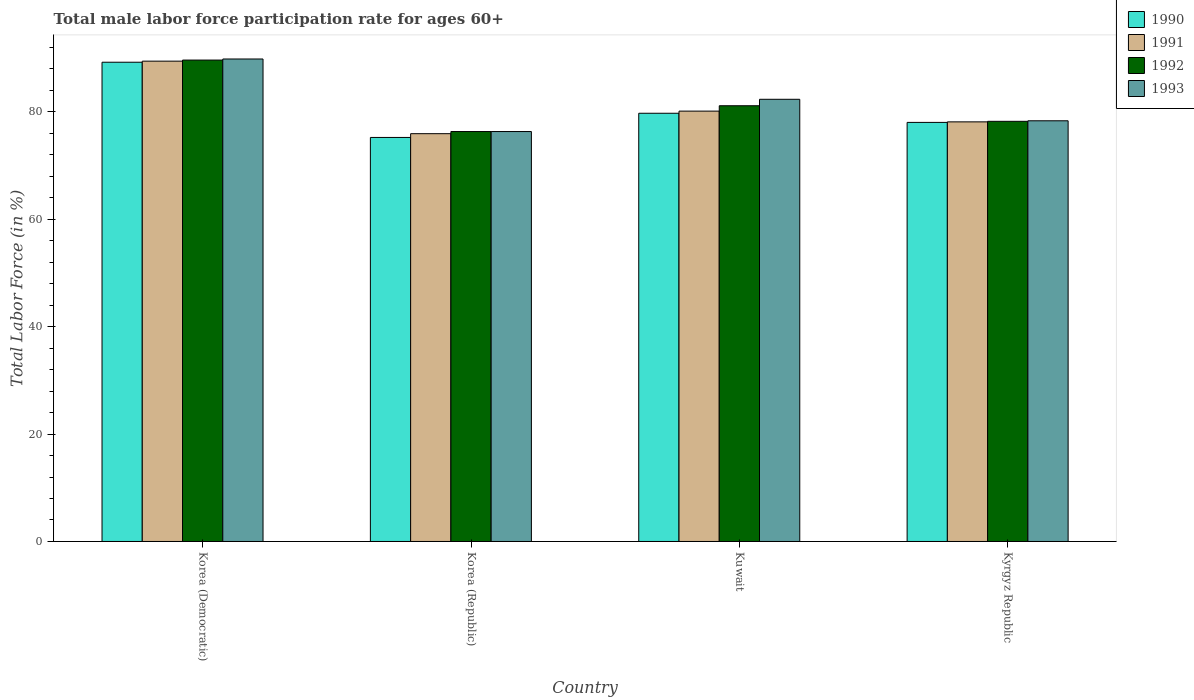How many groups of bars are there?
Make the answer very short. 4. Are the number of bars on each tick of the X-axis equal?
Offer a very short reply. Yes. What is the label of the 3rd group of bars from the left?
Keep it short and to the point. Kuwait. What is the male labor force participation rate in 1990 in Korea (Democratic)?
Give a very brief answer. 89.2. Across all countries, what is the maximum male labor force participation rate in 1991?
Your answer should be compact. 89.4. Across all countries, what is the minimum male labor force participation rate in 1990?
Your answer should be compact. 75.2. In which country was the male labor force participation rate in 1991 maximum?
Offer a very short reply. Korea (Democratic). In which country was the male labor force participation rate in 1993 minimum?
Offer a very short reply. Korea (Republic). What is the total male labor force participation rate in 1990 in the graph?
Ensure brevity in your answer.  322.1. What is the difference between the male labor force participation rate in 1992 in Korea (Republic) and that in Kuwait?
Provide a short and direct response. -4.8. What is the difference between the male labor force participation rate in 1990 in Korea (Republic) and the male labor force participation rate in 1991 in Kuwait?
Offer a terse response. -4.9. What is the average male labor force participation rate in 1991 per country?
Your answer should be very brief. 80.87. What is the ratio of the male labor force participation rate in 1992 in Korea (Republic) to that in Kuwait?
Keep it short and to the point. 0.94. Is the difference between the male labor force participation rate in 1992 in Korea (Democratic) and Kuwait greater than the difference between the male labor force participation rate in 1993 in Korea (Democratic) and Kuwait?
Your answer should be compact. Yes. What is the difference between the highest and the second highest male labor force participation rate in 1991?
Give a very brief answer. -9.3. In how many countries, is the male labor force participation rate in 1993 greater than the average male labor force participation rate in 1993 taken over all countries?
Offer a very short reply. 2. What does the 1st bar from the left in Korea (Republic) represents?
Make the answer very short. 1990. What does the 2nd bar from the right in Kyrgyz Republic represents?
Your response must be concise. 1992. Is it the case that in every country, the sum of the male labor force participation rate in 1992 and male labor force participation rate in 1993 is greater than the male labor force participation rate in 1990?
Make the answer very short. Yes. What is the difference between two consecutive major ticks on the Y-axis?
Provide a short and direct response. 20. Does the graph contain any zero values?
Make the answer very short. No. How are the legend labels stacked?
Your answer should be very brief. Vertical. What is the title of the graph?
Keep it short and to the point. Total male labor force participation rate for ages 60+. What is the label or title of the X-axis?
Keep it short and to the point. Country. What is the Total Labor Force (in %) in 1990 in Korea (Democratic)?
Provide a short and direct response. 89.2. What is the Total Labor Force (in %) in 1991 in Korea (Democratic)?
Your answer should be compact. 89.4. What is the Total Labor Force (in %) of 1992 in Korea (Democratic)?
Your response must be concise. 89.6. What is the Total Labor Force (in %) of 1993 in Korea (Democratic)?
Your answer should be compact. 89.8. What is the Total Labor Force (in %) in 1990 in Korea (Republic)?
Make the answer very short. 75.2. What is the Total Labor Force (in %) in 1991 in Korea (Republic)?
Ensure brevity in your answer.  75.9. What is the Total Labor Force (in %) in 1992 in Korea (Republic)?
Give a very brief answer. 76.3. What is the Total Labor Force (in %) in 1993 in Korea (Republic)?
Your response must be concise. 76.3. What is the Total Labor Force (in %) of 1990 in Kuwait?
Keep it short and to the point. 79.7. What is the Total Labor Force (in %) of 1991 in Kuwait?
Ensure brevity in your answer.  80.1. What is the Total Labor Force (in %) of 1992 in Kuwait?
Give a very brief answer. 81.1. What is the Total Labor Force (in %) in 1993 in Kuwait?
Provide a succinct answer. 82.3. What is the Total Labor Force (in %) in 1991 in Kyrgyz Republic?
Ensure brevity in your answer.  78.1. What is the Total Labor Force (in %) in 1992 in Kyrgyz Republic?
Your response must be concise. 78.2. What is the Total Labor Force (in %) of 1993 in Kyrgyz Republic?
Make the answer very short. 78.3. Across all countries, what is the maximum Total Labor Force (in %) in 1990?
Provide a short and direct response. 89.2. Across all countries, what is the maximum Total Labor Force (in %) of 1991?
Your response must be concise. 89.4. Across all countries, what is the maximum Total Labor Force (in %) of 1992?
Provide a succinct answer. 89.6. Across all countries, what is the maximum Total Labor Force (in %) of 1993?
Provide a short and direct response. 89.8. Across all countries, what is the minimum Total Labor Force (in %) of 1990?
Your response must be concise. 75.2. Across all countries, what is the minimum Total Labor Force (in %) of 1991?
Offer a terse response. 75.9. Across all countries, what is the minimum Total Labor Force (in %) of 1992?
Your response must be concise. 76.3. Across all countries, what is the minimum Total Labor Force (in %) in 1993?
Provide a succinct answer. 76.3. What is the total Total Labor Force (in %) of 1990 in the graph?
Provide a succinct answer. 322.1. What is the total Total Labor Force (in %) of 1991 in the graph?
Keep it short and to the point. 323.5. What is the total Total Labor Force (in %) in 1992 in the graph?
Keep it short and to the point. 325.2. What is the total Total Labor Force (in %) in 1993 in the graph?
Your response must be concise. 326.7. What is the difference between the Total Labor Force (in %) in 1991 in Korea (Democratic) and that in Korea (Republic)?
Your answer should be compact. 13.5. What is the difference between the Total Labor Force (in %) of 1992 in Korea (Democratic) and that in Korea (Republic)?
Provide a succinct answer. 13.3. What is the difference between the Total Labor Force (in %) in 1993 in Korea (Democratic) and that in Korea (Republic)?
Your response must be concise. 13.5. What is the difference between the Total Labor Force (in %) in 1992 in Korea (Democratic) and that in Kuwait?
Keep it short and to the point. 8.5. What is the difference between the Total Labor Force (in %) in 1993 in Korea (Democratic) and that in Kuwait?
Make the answer very short. 7.5. What is the difference between the Total Labor Force (in %) in 1990 in Korea (Democratic) and that in Kyrgyz Republic?
Offer a very short reply. 11.2. What is the difference between the Total Labor Force (in %) of 1991 in Korea (Democratic) and that in Kyrgyz Republic?
Your answer should be compact. 11.3. What is the difference between the Total Labor Force (in %) in 1991 in Korea (Republic) and that in Kuwait?
Offer a very short reply. -4.2. What is the difference between the Total Labor Force (in %) of 1990 in Kuwait and that in Kyrgyz Republic?
Give a very brief answer. 1.7. What is the difference between the Total Labor Force (in %) in 1991 in Kuwait and that in Kyrgyz Republic?
Ensure brevity in your answer.  2. What is the difference between the Total Labor Force (in %) in 1992 in Kuwait and that in Kyrgyz Republic?
Provide a short and direct response. 2.9. What is the difference between the Total Labor Force (in %) in 1993 in Kuwait and that in Kyrgyz Republic?
Give a very brief answer. 4. What is the difference between the Total Labor Force (in %) of 1990 in Korea (Democratic) and the Total Labor Force (in %) of 1991 in Korea (Republic)?
Your response must be concise. 13.3. What is the difference between the Total Labor Force (in %) of 1990 in Korea (Democratic) and the Total Labor Force (in %) of 1992 in Korea (Republic)?
Make the answer very short. 12.9. What is the difference between the Total Labor Force (in %) in 1990 in Korea (Democratic) and the Total Labor Force (in %) in 1993 in Korea (Republic)?
Provide a succinct answer. 12.9. What is the difference between the Total Labor Force (in %) in 1991 in Korea (Democratic) and the Total Labor Force (in %) in 1992 in Korea (Republic)?
Offer a terse response. 13.1. What is the difference between the Total Labor Force (in %) in 1991 in Korea (Democratic) and the Total Labor Force (in %) in 1993 in Korea (Republic)?
Keep it short and to the point. 13.1. What is the difference between the Total Labor Force (in %) of 1992 in Korea (Democratic) and the Total Labor Force (in %) of 1993 in Korea (Republic)?
Give a very brief answer. 13.3. What is the difference between the Total Labor Force (in %) in 1990 in Korea (Democratic) and the Total Labor Force (in %) in 1991 in Kuwait?
Your response must be concise. 9.1. What is the difference between the Total Labor Force (in %) of 1991 in Korea (Democratic) and the Total Labor Force (in %) of 1992 in Kuwait?
Provide a succinct answer. 8.3. What is the difference between the Total Labor Force (in %) in 1990 in Korea (Democratic) and the Total Labor Force (in %) in 1991 in Kyrgyz Republic?
Your answer should be compact. 11.1. What is the difference between the Total Labor Force (in %) of 1990 in Korea (Democratic) and the Total Labor Force (in %) of 1993 in Kyrgyz Republic?
Keep it short and to the point. 10.9. What is the difference between the Total Labor Force (in %) in 1990 in Korea (Republic) and the Total Labor Force (in %) in 1991 in Kuwait?
Make the answer very short. -4.9. What is the difference between the Total Labor Force (in %) in 1991 in Korea (Republic) and the Total Labor Force (in %) in 1992 in Kuwait?
Provide a succinct answer. -5.2. What is the difference between the Total Labor Force (in %) in 1992 in Korea (Republic) and the Total Labor Force (in %) in 1993 in Kyrgyz Republic?
Keep it short and to the point. -2. What is the difference between the Total Labor Force (in %) in 1990 in Kuwait and the Total Labor Force (in %) in 1993 in Kyrgyz Republic?
Offer a terse response. 1.4. What is the difference between the Total Labor Force (in %) of 1991 in Kuwait and the Total Labor Force (in %) of 1993 in Kyrgyz Republic?
Ensure brevity in your answer.  1.8. What is the average Total Labor Force (in %) in 1990 per country?
Provide a short and direct response. 80.53. What is the average Total Labor Force (in %) in 1991 per country?
Provide a short and direct response. 80.88. What is the average Total Labor Force (in %) in 1992 per country?
Provide a succinct answer. 81.3. What is the average Total Labor Force (in %) of 1993 per country?
Your response must be concise. 81.67. What is the difference between the Total Labor Force (in %) of 1990 and Total Labor Force (in %) of 1991 in Korea (Democratic)?
Offer a terse response. -0.2. What is the difference between the Total Labor Force (in %) of 1990 and Total Labor Force (in %) of 1992 in Korea (Democratic)?
Keep it short and to the point. -0.4. What is the difference between the Total Labor Force (in %) in 1990 and Total Labor Force (in %) in 1993 in Korea (Democratic)?
Make the answer very short. -0.6. What is the difference between the Total Labor Force (in %) in 1991 and Total Labor Force (in %) in 1992 in Korea (Democratic)?
Make the answer very short. -0.2. What is the difference between the Total Labor Force (in %) in 1990 and Total Labor Force (in %) in 1991 in Korea (Republic)?
Your response must be concise. -0.7. What is the difference between the Total Labor Force (in %) in 1991 and Total Labor Force (in %) in 1992 in Korea (Republic)?
Provide a short and direct response. -0.4. What is the difference between the Total Labor Force (in %) in 1992 and Total Labor Force (in %) in 1993 in Korea (Republic)?
Your response must be concise. 0. What is the difference between the Total Labor Force (in %) of 1990 and Total Labor Force (in %) of 1991 in Kuwait?
Make the answer very short. -0.4. What is the difference between the Total Labor Force (in %) in 1991 and Total Labor Force (in %) in 1992 in Kuwait?
Provide a succinct answer. -1. What is the difference between the Total Labor Force (in %) in 1990 and Total Labor Force (in %) in 1991 in Kyrgyz Republic?
Offer a terse response. -0.1. What is the difference between the Total Labor Force (in %) of 1990 and Total Labor Force (in %) of 1992 in Kyrgyz Republic?
Provide a succinct answer. -0.2. What is the difference between the Total Labor Force (in %) in 1991 and Total Labor Force (in %) in 1993 in Kyrgyz Republic?
Your answer should be very brief. -0.2. What is the difference between the Total Labor Force (in %) of 1992 and Total Labor Force (in %) of 1993 in Kyrgyz Republic?
Offer a terse response. -0.1. What is the ratio of the Total Labor Force (in %) of 1990 in Korea (Democratic) to that in Korea (Republic)?
Keep it short and to the point. 1.19. What is the ratio of the Total Labor Force (in %) in 1991 in Korea (Democratic) to that in Korea (Republic)?
Your answer should be very brief. 1.18. What is the ratio of the Total Labor Force (in %) of 1992 in Korea (Democratic) to that in Korea (Republic)?
Your response must be concise. 1.17. What is the ratio of the Total Labor Force (in %) of 1993 in Korea (Democratic) to that in Korea (Republic)?
Offer a very short reply. 1.18. What is the ratio of the Total Labor Force (in %) in 1990 in Korea (Democratic) to that in Kuwait?
Provide a short and direct response. 1.12. What is the ratio of the Total Labor Force (in %) of 1991 in Korea (Democratic) to that in Kuwait?
Provide a succinct answer. 1.12. What is the ratio of the Total Labor Force (in %) in 1992 in Korea (Democratic) to that in Kuwait?
Ensure brevity in your answer.  1.1. What is the ratio of the Total Labor Force (in %) in 1993 in Korea (Democratic) to that in Kuwait?
Keep it short and to the point. 1.09. What is the ratio of the Total Labor Force (in %) in 1990 in Korea (Democratic) to that in Kyrgyz Republic?
Provide a succinct answer. 1.14. What is the ratio of the Total Labor Force (in %) in 1991 in Korea (Democratic) to that in Kyrgyz Republic?
Provide a succinct answer. 1.14. What is the ratio of the Total Labor Force (in %) in 1992 in Korea (Democratic) to that in Kyrgyz Republic?
Offer a terse response. 1.15. What is the ratio of the Total Labor Force (in %) of 1993 in Korea (Democratic) to that in Kyrgyz Republic?
Provide a succinct answer. 1.15. What is the ratio of the Total Labor Force (in %) of 1990 in Korea (Republic) to that in Kuwait?
Offer a terse response. 0.94. What is the ratio of the Total Labor Force (in %) of 1991 in Korea (Republic) to that in Kuwait?
Offer a terse response. 0.95. What is the ratio of the Total Labor Force (in %) in 1992 in Korea (Republic) to that in Kuwait?
Offer a terse response. 0.94. What is the ratio of the Total Labor Force (in %) in 1993 in Korea (Republic) to that in Kuwait?
Offer a very short reply. 0.93. What is the ratio of the Total Labor Force (in %) of 1990 in Korea (Republic) to that in Kyrgyz Republic?
Offer a terse response. 0.96. What is the ratio of the Total Labor Force (in %) of 1991 in Korea (Republic) to that in Kyrgyz Republic?
Your answer should be compact. 0.97. What is the ratio of the Total Labor Force (in %) of 1992 in Korea (Republic) to that in Kyrgyz Republic?
Ensure brevity in your answer.  0.98. What is the ratio of the Total Labor Force (in %) of 1993 in Korea (Republic) to that in Kyrgyz Republic?
Provide a short and direct response. 0.97. What is the ratio of the Total Labor Force (in %) in 1990 in Kuwait to that in Kyrgyz Republic?
Your answer should be compact. 1.02. What is the ratio of the Total Labor Force (in %) in 1991 in Kuwait to that in Kyrgyz Republic?
Make the answer very short. 1.03. What is the ratio of the Total Labor Force (in %) of 1992 in Kuwait to that in Kyrgyz Republic?
Your answer should be very brief. 1.04. What is the ratio of the Total Labor Force (in %) in 1993 in Kuwait to that in Kyrgyz Republic?
Offer a terse response. 1.05. What is the difference between the highest and the second highest Total Labor Force (in %) of 1993?
Make the answer very short. 7.5. What is the difference between the highest and the lowest Total Labor Force (in %) in 1990?
Give a very brief answer. 14. What is the difference between the highest and the lowest Total Labor Force (in %) of 1991?
Provide a short and direct response. 13.5. What is the difference between the highest and the lowest Total Labor Force (in %) in 1992?
Your answer should be very brief. 13.3. 